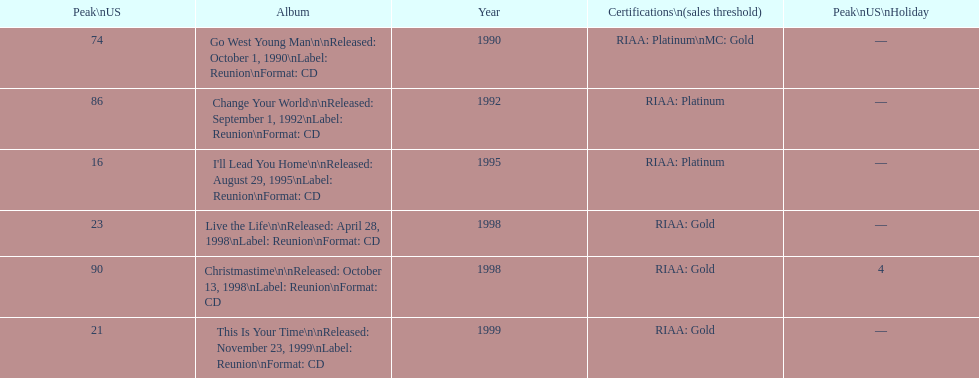Would you mind parsing the complete table? {'header': ['Peak\\nUS', 'Album', 'Year', 'Certifications\\n(sales threshold)', 'Peak\\nUS\\nHoliday'], 'rows': [['74', 'Go West Young Man\\n\\nReleased: October 1, 1990\\nLabel: Reunion\\nFormat: CD', '1990', 'RIAA: Platinum\\nMC: Gold', '—'], ['86', 'Change Your World\\n\\nReleased: September 1, 1992\\nLabel: Reunion\\nFormat: CD', '1992', 'RIAA: Platinum', '—'], ['16', "I'll Lead You Home\\n\\nReleased: August 29, 1995\\nLabel: Reunion\\nFormat: CD", '1995', 'RIAA: Platinum', '—'], ['23', 'Live the Life\\n\\nReleased: April 28, 1998\\nLabel: Reunion\\nFormat: CD', '1998', 'RIAA: Gold', '—'], ['90', 'Christmastime\\n\\nReleased: October 13, 1998\\nLabel: Reunion\\nFormat: CD', '1998', 'RIAA: Gold', '4'], ['21', 'This Is Your Time\\n\\nReleased: November 23, 1999\\nLabel: Reunion\\nFormat: CD', '1999', 'RIAA: Gold', '—']]} How many album entries are there? 6. 